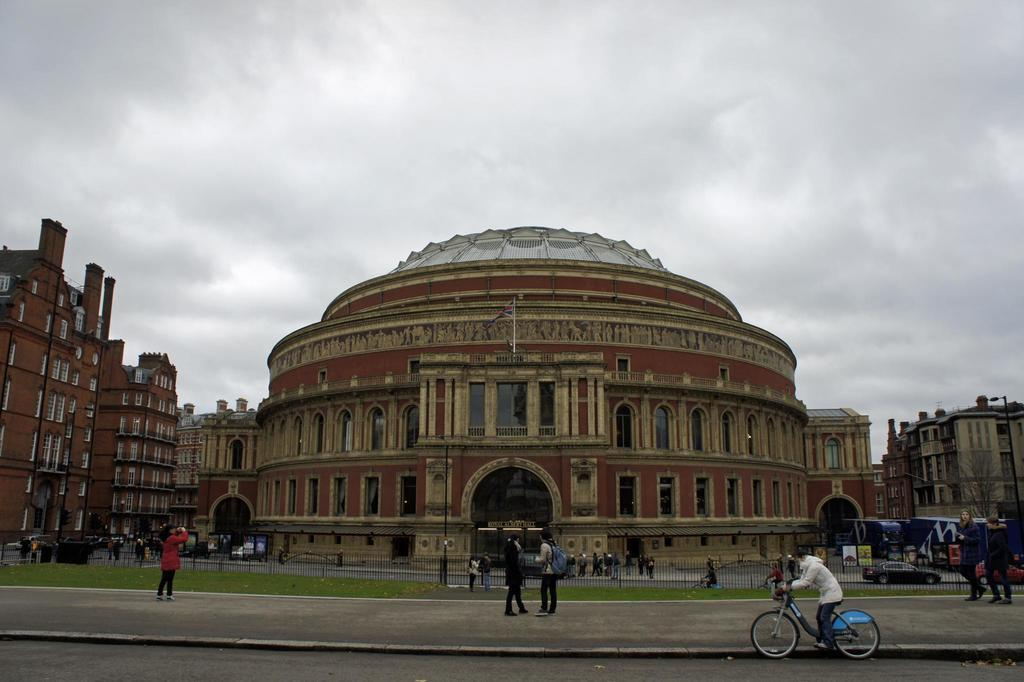What can be seen in the sky in the image? The sky with clouds is visible in the image. What type of structures are present in the image? There are buildings in the image. What objects are used for cooking in the image? Grills are present in the image. What items are used for waste disposal in the image? Bins are visible in the image. What are the people in the image doing? There are persons standing on the road and a person sitting on a bicycle in the image. What mode of transportation is present in the image? A motor vehicle is present in the image. What type of vegetation is visible in the image? Trees are visible in the image. What objects are used for supporting wires or signs in the image? Poles are present in the image. What type of animal is the zebra in the image? There is no zebra present in the image. What tool does the carpenter use in the image? There is no carpenter or tool present in the image. What object is used for cutting in the image? There is no knife or cutting object present in the image. 